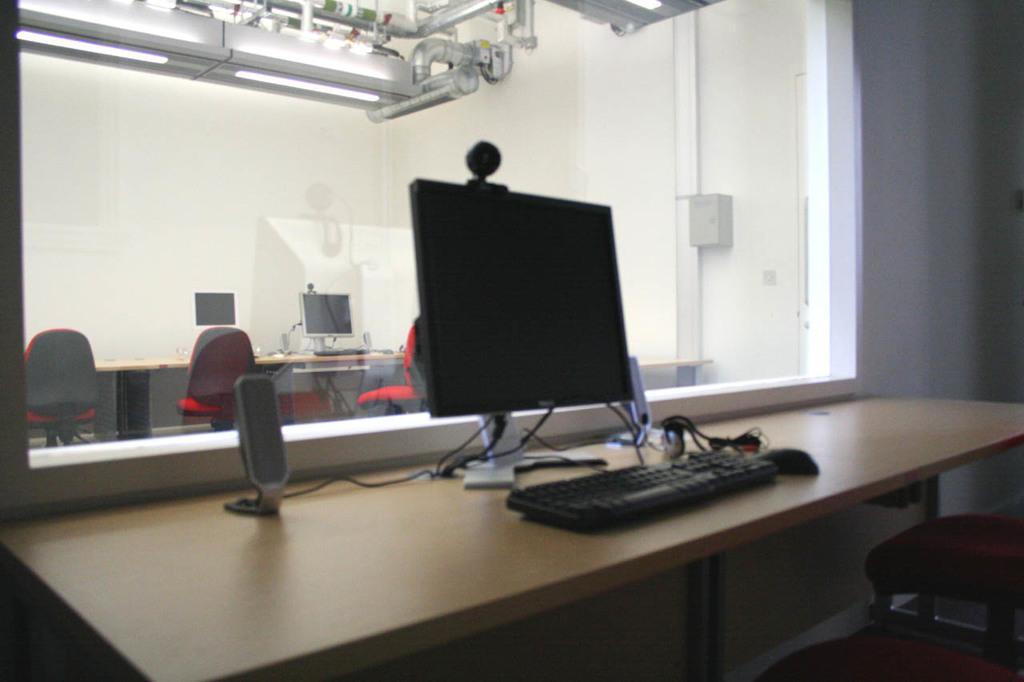How would you summarize this image in a sentence or two? We can see monitor,mouse,keyboard,cables and objects on the table and we can see chairs. We can see glass and wall,through this glass we can see monitor and objects on the table and chairs,at the top we can see lights and rods. 